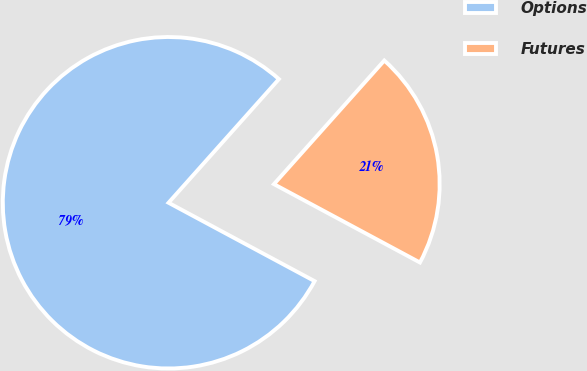<chart> <loc_0><loc_0><loc_500><loc_500><pie_chart><fcel>Options<fcel>Futures<nl><fcel>78.76%<fcel>21.24%<nl></chart> 